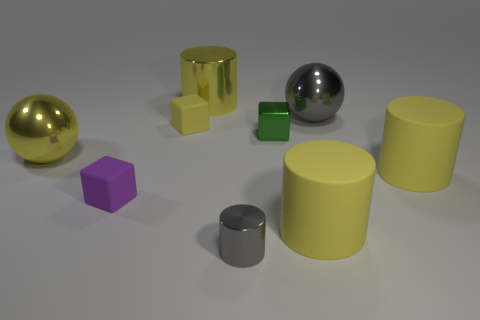Subtract all purple balls. How many yellow cylinders are left? 3 Subtract all green cylinders. Subtract all cyan spheres. How many cylinders are left? 4 Subtract all cylinders. How many objects are left? 5 Subtract all cyan metal cylinders. Subtract all metal objects. How many objects are left? 4 Add 9 tiny yellow cubes. How many tiny yellow cubes are left? 10 Add 8 big gray metallic things. How many big gray metallic things exist? 9 Subtract 1 gray cylinders. How many objects are left? 8 